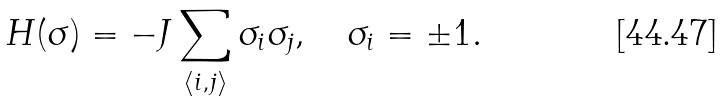<formula> <loc_0><loc_0><loc_500><loc_500>H ( \sigma ) = - J \sum _ { \langle i , j \rangle } \sigma _ { i } \sigma _ { j } , \quad \sigma _ { i } = \pm 1 .</formula> 